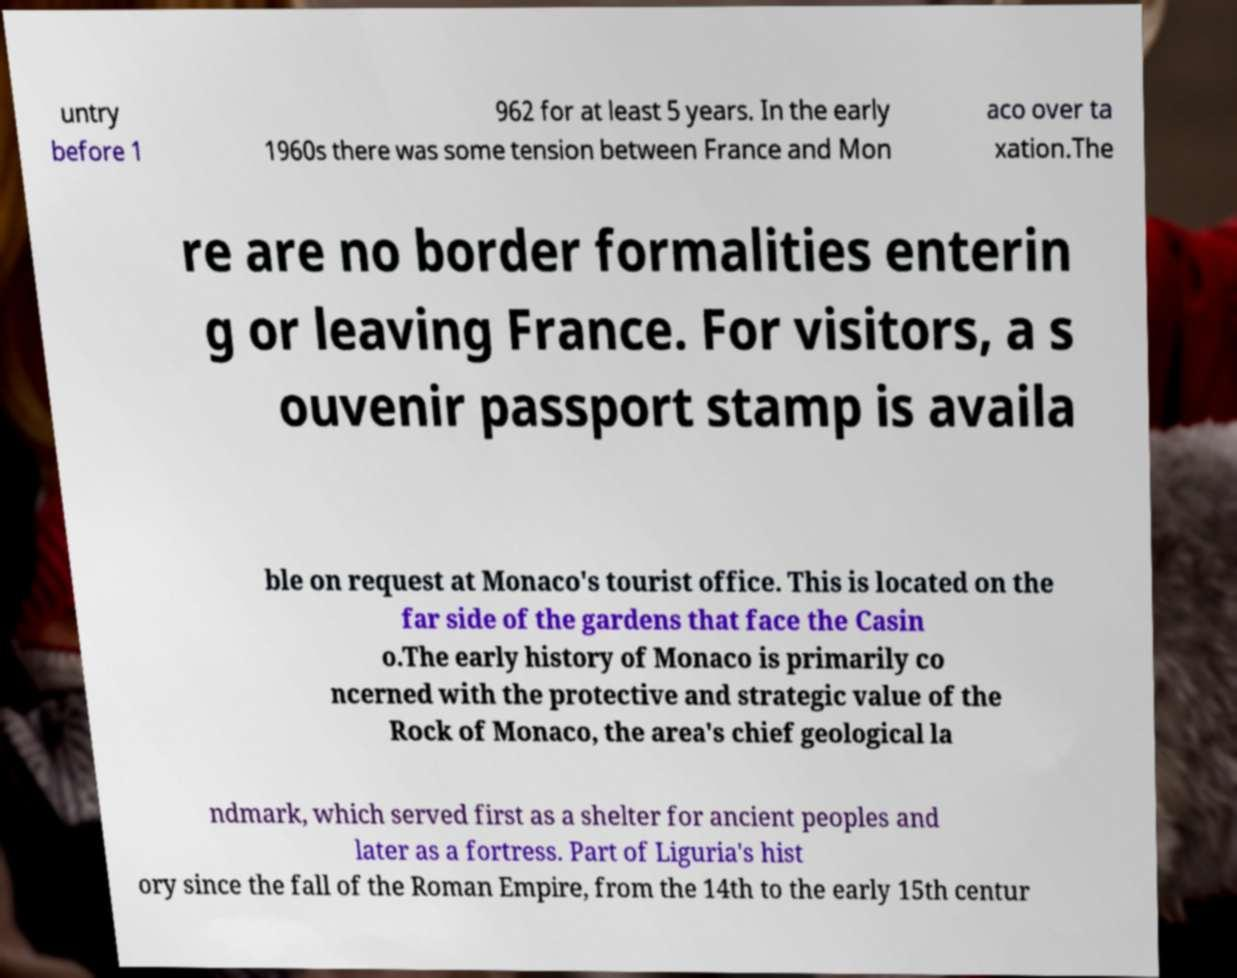Can you read and provide the text displayed in the image?This photo seems to have some interesting text. Can you extract and type it out for me? untry before 1 962 for at least 5 years. In the early 1960s there was some tension between France and Mon aco over ta xation.The re are no border formalities enterin g or leaving France. For visitors, a s ouvenir passport stamp is availa ble on request at Monaco's tourist office. This is located on the far side of the gardens that face the Casin o.The early history of Monaco is primarily co ncerned with the protective and strategic value of the Rock of Monaco, the area's chief geological la ndmark, which served first as a shelter for ancient peoples and later as a fortress. Part of Liguria's hist ory since the fall of the Roman Empire, from the 14th to the early 15th centur 